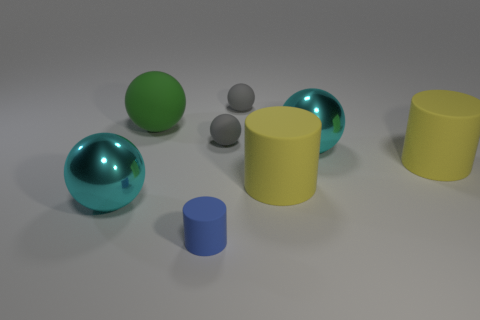How many cyan spheres are behind the big green object?
Ensure brevity in your answer.  0. How big is the green rubber thing?
Your answer should be very brief. Large. What is the color of the small cylinder that is made of the same material as the big green object?
Offer a very short reply. Blue. How many green objects have the same size as the green matte ball?
Offer a very short reply. 0. Does the big cyan sphere that is left of the big green rubber ball have the same material as the big green ball?
Keep it short and to the point. No. Is the number of green matte balls that are to the right of the blue cylinder less than the number of gray balls?
Provide a short and direct response. Yes. What is the shape of the blue rubber object right of the green sphere?
Your answer should be compact. Cylinder. Is there another large rubber thing that has the same shape as the blue object?
Keep it short and to the point. Yes. Is the shape of the object left of the big green sphere the same as the matte object that is to the left of the blue cylinder?
Offer a terse response. Yes. What number of other things are there of the same material as the blue thing
Ensure brevity in your answer.  5. 